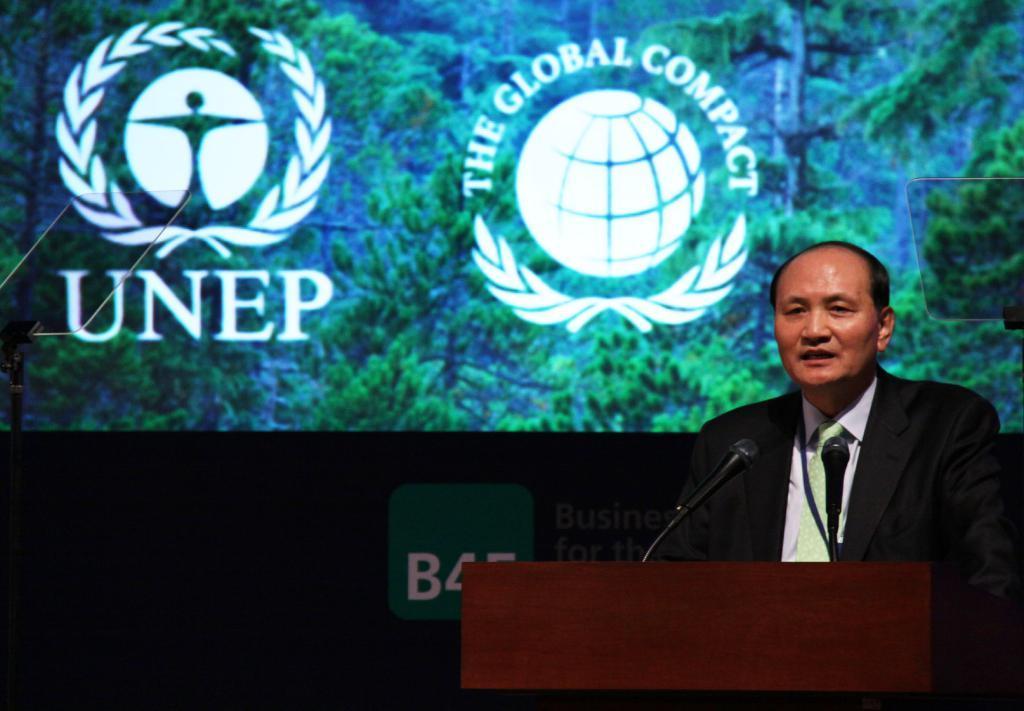Could you give a brief overview of what you see in this image? In this image we can see a man standing behind a podium containing microphones on it. On the right side of the image we can see a glass sheet. At the top of the image we can see a screen on which we can see text and some trees. 